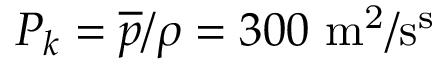<formula> <loc_0><loc_0><loc_500><loc_500>P _ { k } = \overline { p } / \rho = 3 0 0 m ^ { 2 } / s ^ { s }</formula> 